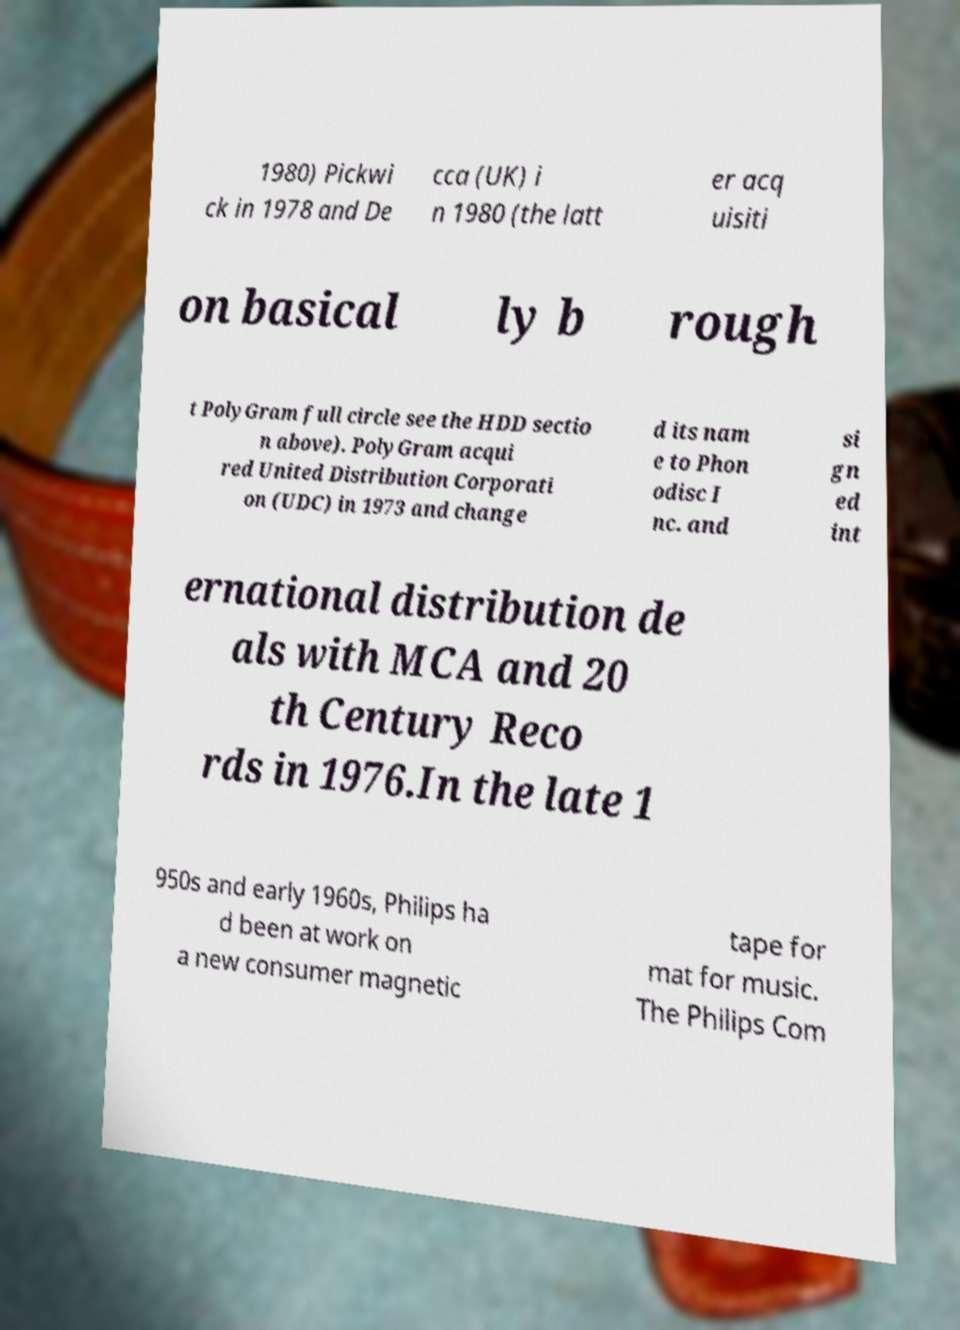There's text embedded in this image that I need extracted. Can you transcribe it verbatim? 1980) Pickwi ck in 1978 and De cca (UK) i n 1980 (the latt er acq uisiti on basical ly b rough t PolyGram full circle see the HDD sectio n above). PolyGram acqui red United Distribution Corporati on (UDC) in 1973 and change d its nam e to Phon odisc I nc. and si gn ed int ernational distribution de als with MCA and 20 th Century Reco rds in 1976.In the late 1 950s and early 1960s, Philips ha d been at work on a new consumer magnetic tape for mat for music. The Philips Com 